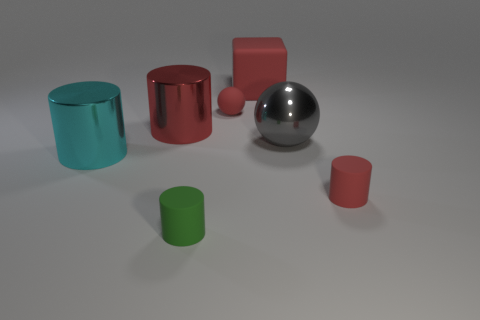Is the color of the large block the same as the rubber ball?
Make the answer very short. Yes. How many cyan metallic things are the same size as the red metallic object?
Your response must be concise. 1. What shape is the shiny object that is the same color as the small ball?
Provide a succinct answer. Cylinder. There is a tiny object that is on the right side of the big red block; are there any red cylinders that are on the left side of it?
Make the answer very short. Yes. What number of objects are cyan metallic cylinders that are to the left of the red rubber block or big blue balls?
Ensure brevity in your answer.  1. What number of red cylinders are there?
Offer a terse response. 2. What is the shape of the gray object that is the same material as the large cyan cylinder?
Your response must be concise. Sphere. What is the size of the red cylinder behind the tiny rubber object that is to the right of the big gray metallic object?
Keep it short and to the point. Large. What number of objects are either small red objects that are on the right side of the tiny ball or small matte things that are in front of the big ball?
Provide a succinct answer. 2. Is the number of tiny gray rubber objects less than the number of red matte objects?
Your response must be concise. Yes. 